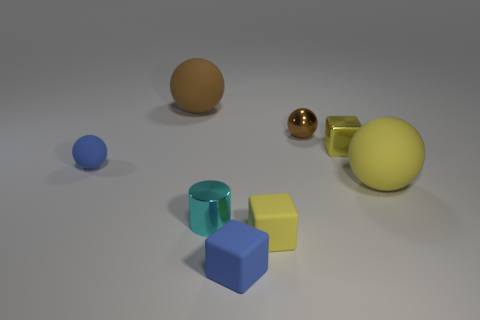The large rubber object in front of the small thing that is to the left of the big sphere that is left of the metallic ball is what shape?
Your response must be concise. Sphere. What number of yellow objects are metallic objects or tiny blocks?
Make the answer very short. 2. How many other things are the same size as the cylinder?
Make the answer very short. 5. How many yellow things are there?
Your response must be concise. 3. Is there any other thing that is the same shape as the tiny yellow metallic object?
Give a very brief answer. Yes. Does the yellow cube that is behind the tiny cyan object have the same material as the big ball that is on the right side of the cyan metal cylinder?
Offer a very short reply. No. What material is the cyan object?
Your answer should be compact. Metal. What number of small brown things have the same material as the large brown object?
Your answer should be very brief. 0. What number of metal objects are tiny yellow blocks or red spheres?
Make the answer very short. 1. Do the tiny yellow object in front of the blue rubber ball and the rubber thing behind the small yellow metal block have the same shape?
Keep it short and to the point. No. 